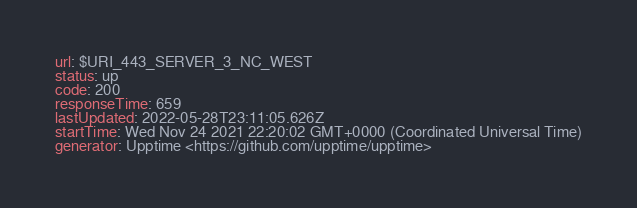<code> <loc_0><loc_0><loc_500><loc_500><_YAML_>url: $URI_443_SERVER_3_NC_WEST
status: up
code: 200
responseTime: 659
lastUpdated: 2022-05-28T23:11:05.626Z
startTime: Wed Nov 24 2021 22:20:02 GMT+0000 (Coordinated Universal Time)
generator: Upptime <https://github.com/upptime/upptime>
</code> 